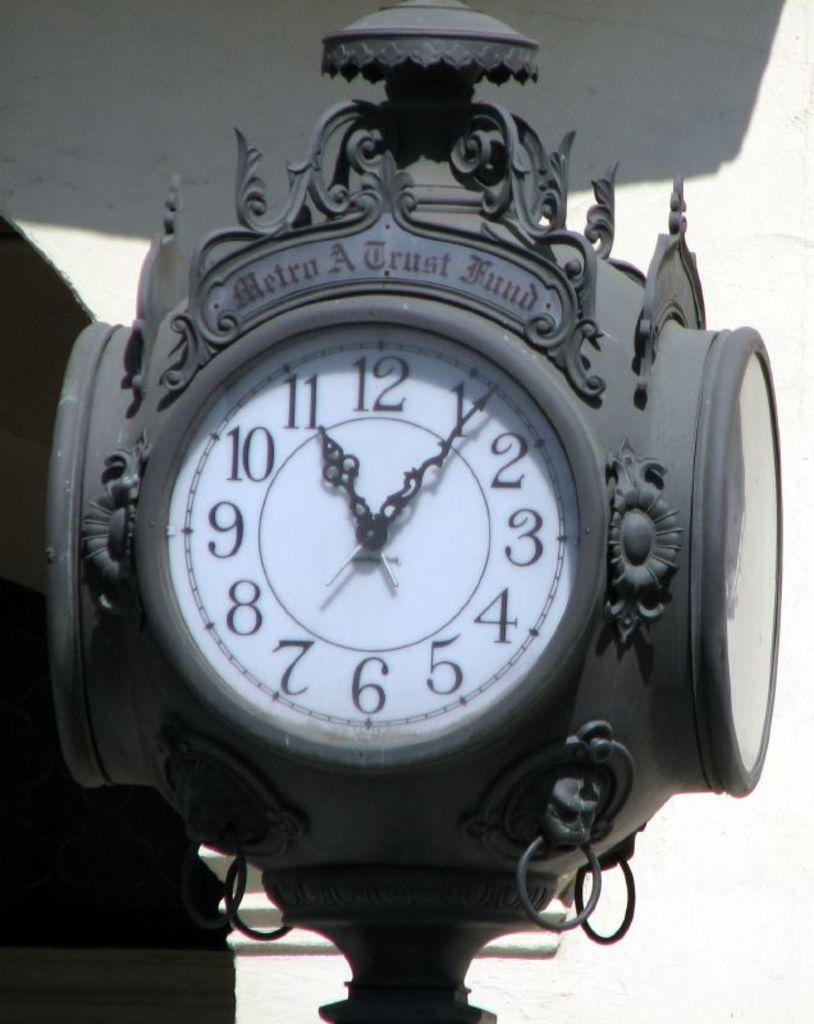Provide a one-sentence caption for the provided image. a Metro A fund clock has 4 faces and is grey. 